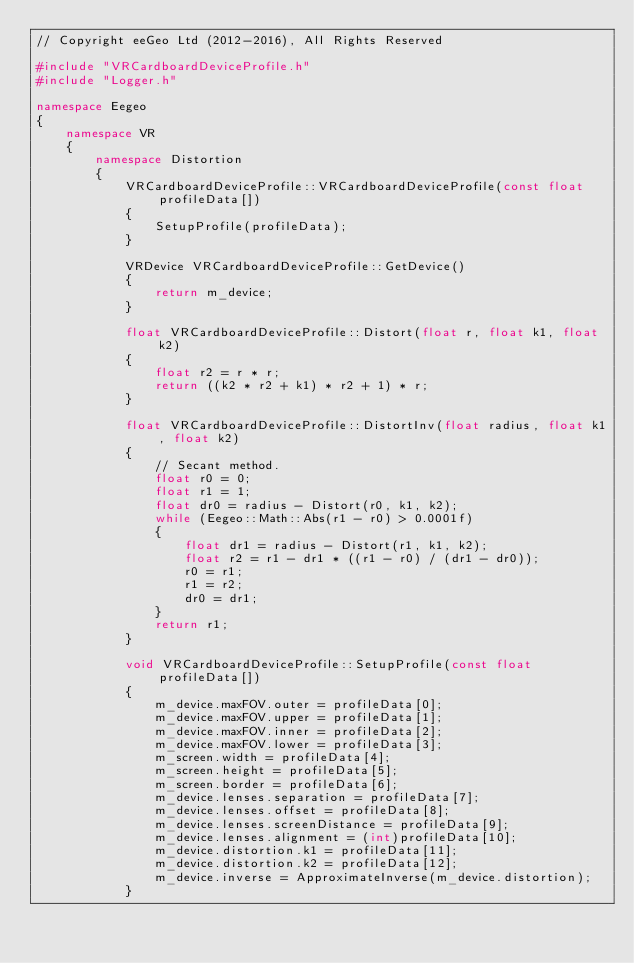Convert code to text. <code><loc_0><loc_0><loc_500><loc_500><_C++_>// Copyright eeGeo Ltd (2012-2016), All Rights Reserved

#include "VRCardboardDeviceProfile.h"
#include "Logger.h"

namespace Eegeo
{
    namespace VR
    {
        namespace Distortion
        {
            VRCardboardDeviceProfile::VRCardboardDeviceProfile(const float profileData[])
            {
                SetupProfile(profileData);
            }

            VRDevice VRCardboardDeviceProfile::GetDevice()
            {
                return m_device;
            }

            float VRCardboardDeviceProfile::Distort(float r, float k1, float k2)
            {
                float r2 = r * r;
                return ((k2 * r2 + k1) * r2 + 1) * r;
            }

            float VRCardboardDeviceProfile::DistortInv(float radius, float k1, float k2)
            {
                // Secant method.
                float r0 = 0;
                float r1 = 1;
                float dr0 = radius - Distort(r0, k1, k2);
                while (Eegeo::Math::Abs(r1 - r0) > 0.0001f)
                {
                    float dr1 = radius - Distort(r1, k1, k2);
                    float r2 = r1 - dr1 * ((r1 - r0) / (dr1 - dr0));
                    r0 = r1;
                    r1 = r2;
                    dr0 = dr1;
                }
                return r1;
            }

            void VRCardboardDeviceProfile::SetupProfile(const float profileData[])
            {
                m_device.maxFOV.outer = profileData[0];
                m_device.maxFOV.upper = profileData[1];
                m_device.maxFOV.inner = profileData[2];
                m_device.maxFOV.lower = profileData[3];
                m_screen.width = profileData[4];
                m_screen.height = profileData[5];
                m_screen.border = profileData[6];
                m_device.lenses.separation = profileData[7];
                m_device.lenses.offset = profileData[8];
                m_device.lenses.screenDistance = profileData[9];
                m_device.lenses.alignment = (int)profileData[10];
                m_device.distortion.k1 = profileData[11];
                m_device.distortion.k2 = profileData[12];
                m_device.inverse = ApproximateInverse(m_device.distortion);
            }
</code> 